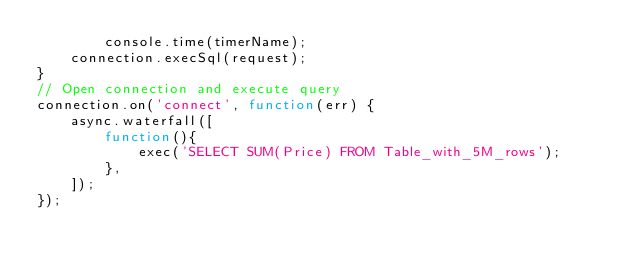Convert code to text. <code><loc_0><loc_0><loc_500><loc_500><_JavaScript_>        console.time(timerName);
    connection.execSql(request);
}
// Open connection and execute query
connection.on('connect', function(err) {
    async.waterfall([
        function(){
            exec('SELECT SUM(Price) FROM Table_with_5M_rows');
        },
    ]);
});</code> 